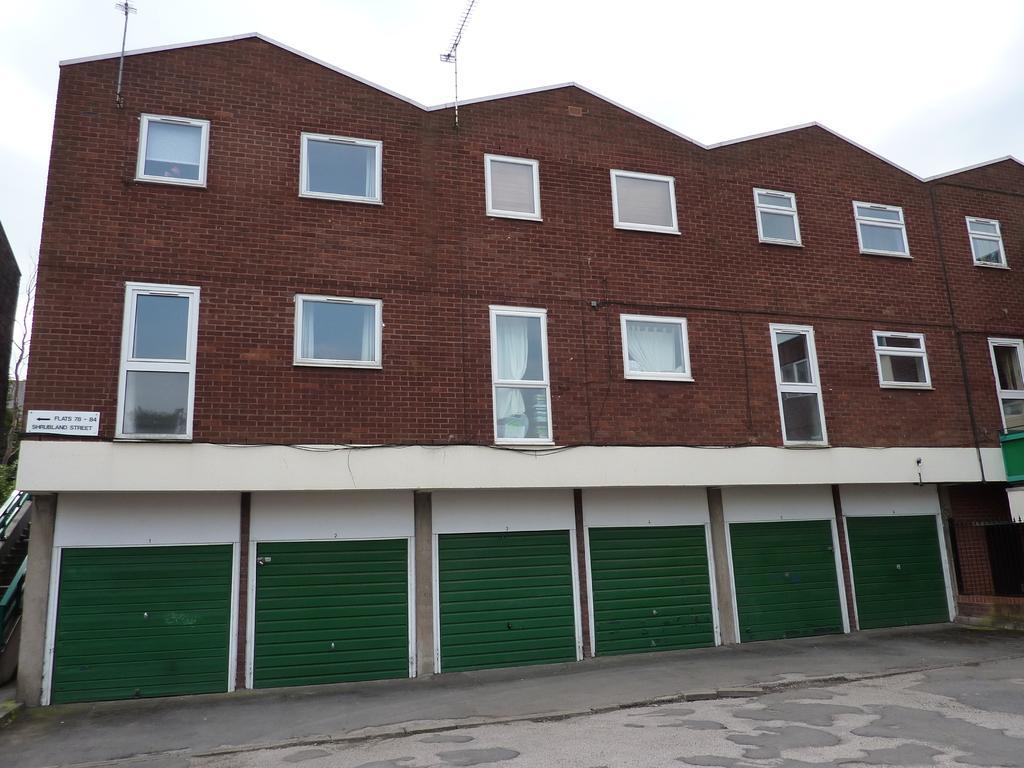In one or two sentences, can you explain what this image depicts? In this image in the background there is a building and on the top of the building there are antennae and in the front of the building there is a road and the sky is cloudy. On the left side there is an object which is black in colour and there is a tree. 